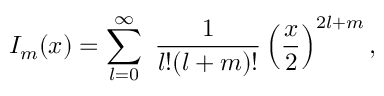<formula> <loc_0><loc_0><loc_500><loc_500>I _ { m } ( x ) = \sum _ { l = 0 } ^ { \infty } \ \frac { 1 } { l ! ( l + m ) ! } \left ( \frac { x } { 2 } \right ) ^ { 2 l + m } ,</formula> 